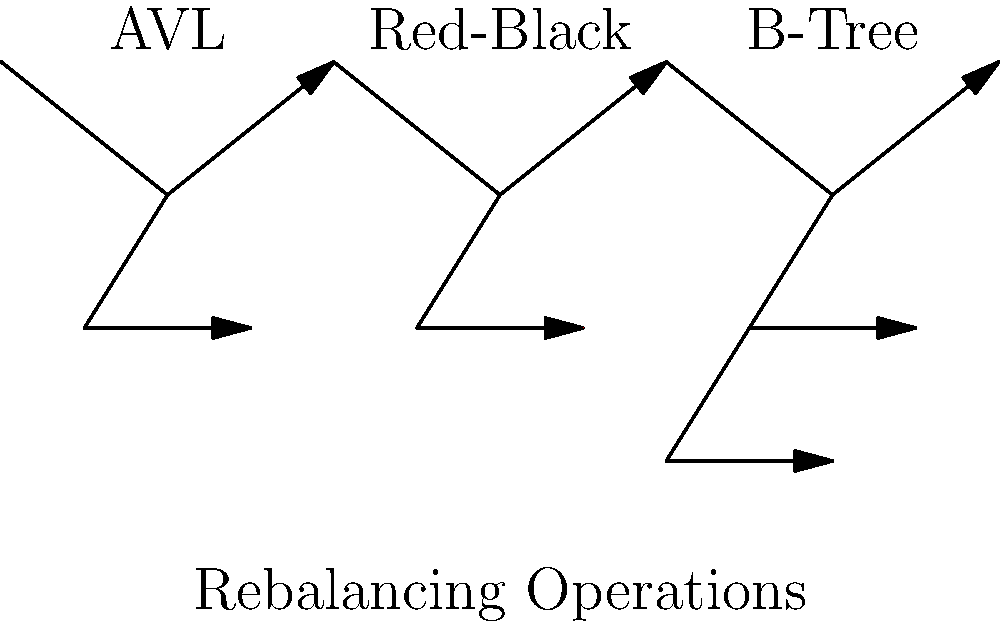Consider the three balanced tree structures shown in the diagram: AVL, Red-Black, and B-tree. Which of these structures typically requires the least number of rotations during rebalancing operations after insertions and deletions? Let's analyze each tree structure:

1. AVL Trees:
   - Strictly balanced (height difference ≤ 1 between subtrees)
   - Requires rotations after every insertion or deletion that violates balance
   - Average case: $O(\log n)$ rotations
   - Worst case: $O(\log n)$ rotations

2. Red-Black Trees:
   - Less strictly balanced than AVL trees
   - Uses color properties to maintain balance
   - Requires fewer rotations compared to AVL trees
   - Average case: $O(1)$ rotations
   - Worst case: $O(\log n)$ rotations

3. B-trees:
   - Designed for efficient disk access and large datasets
   - Nodes can have multiple keys and children
   - Rebalancing often involves splitting or merging nodes
   - Average case: $O(1)$ splits/merges
   - Worst case: $O(\log_m n)$ splits/merges, where $m$ is the minimum degree of the B-tree

Comparing these structures:

- AVL trees require the most frequent rotations due to strict balance requirements.
- Red-Black trees require fewer rotations than AVL trees, as they allow more imbalance.
- B-trees typically require the least number of structural changes during rebalancing, as they can accommodate multiple keys per node and have a higher branching factor.

Therefore, among these three structures, B-trees generally require the least number of rotations (or equivalent operations) during rebalancing.
Answer: B-tree 